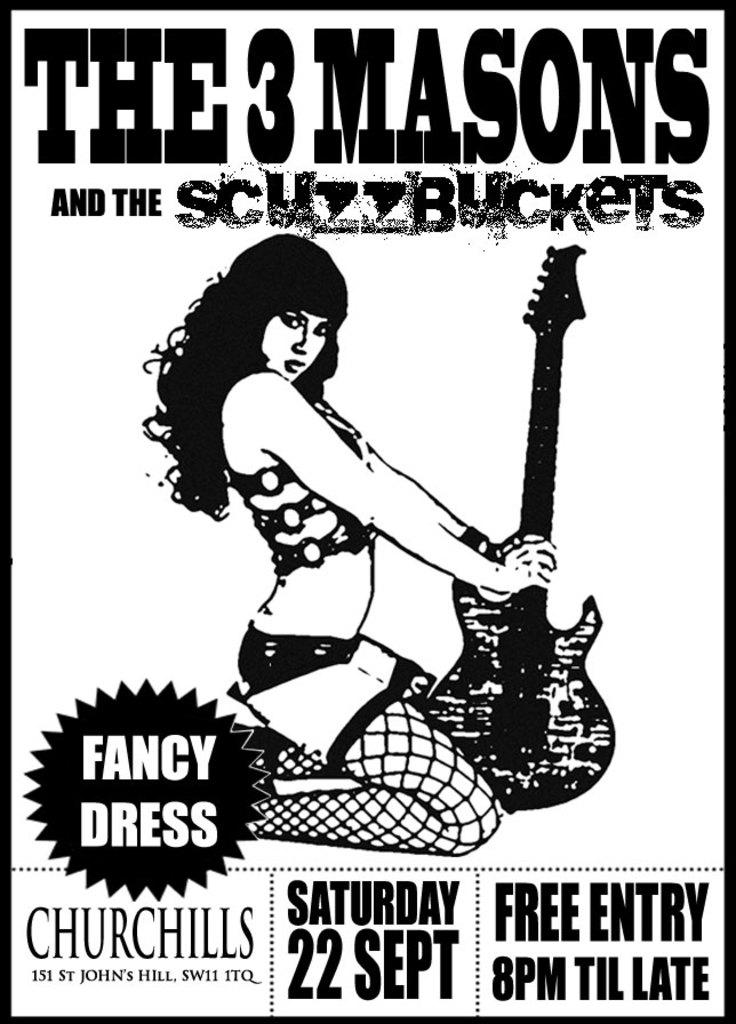Provide a one-sentence caption for the provided image. A black and white poster has a picture of a scantily clad woman holding a guitar and advertises The # Mason and the Scuzzbuckets playing on Saturday, 22 Sept. 